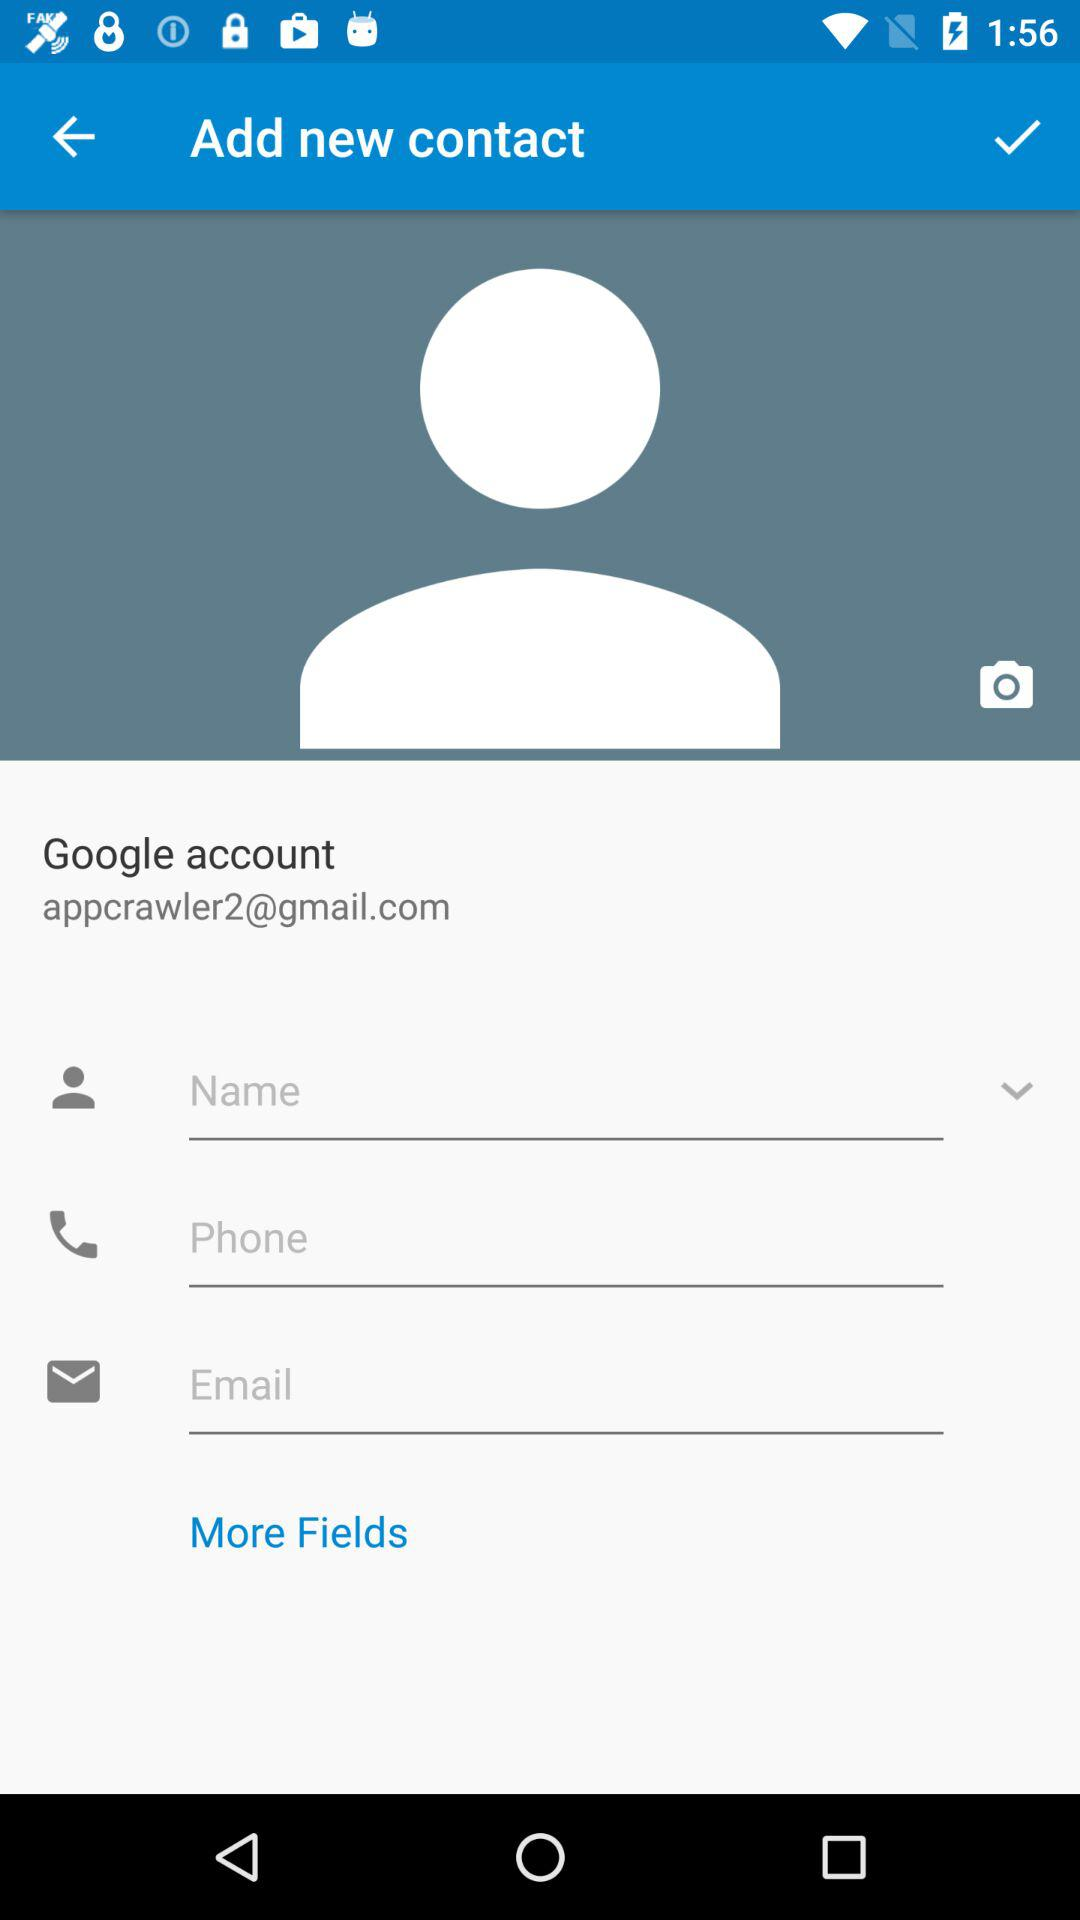How many fields are in the contact form?
Answer the question using a single word or phrase. 3 